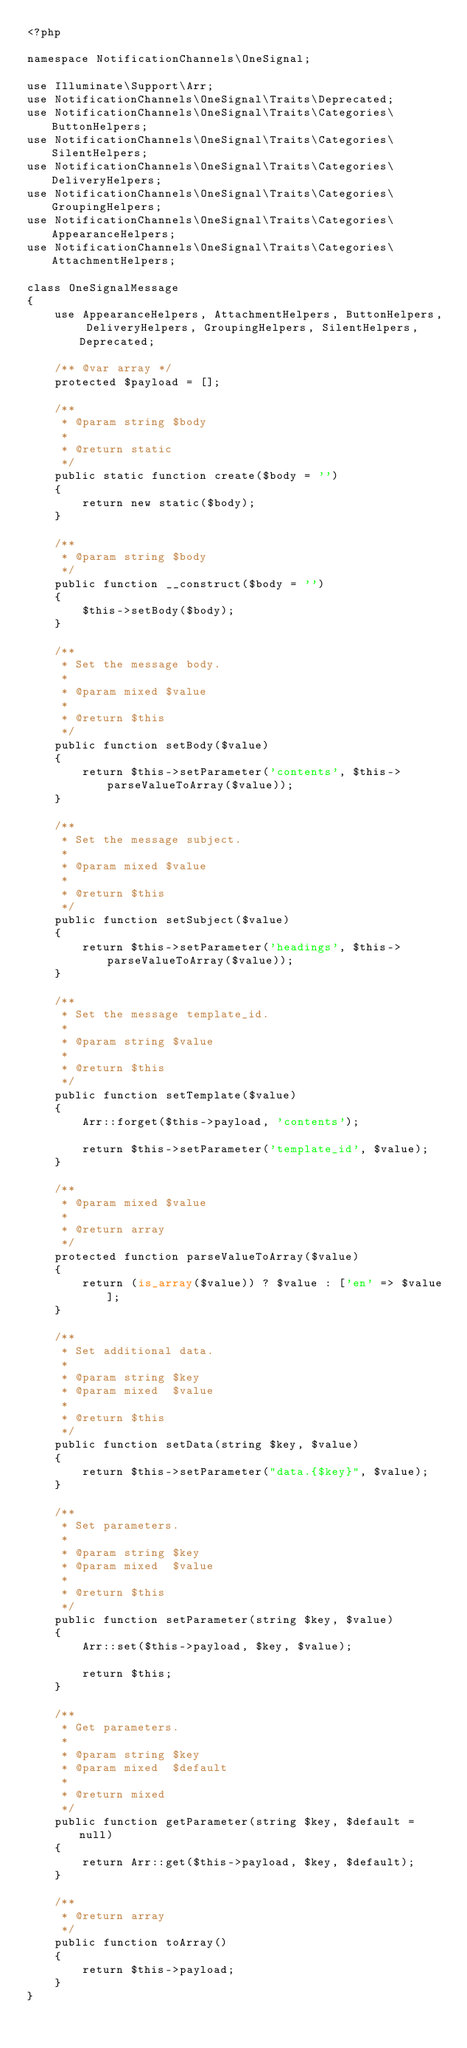<code> <loc_0><loc_0><loc_500><loc_500><_PHP_><?php

namespace NotificationChannels\OneSignal;

use Illuminate\Support\Arr;
use NotificationChannels\OneSignal\Traits\Deprecated;
use NotificationChannels\OneSignal\Traits\Categories\ButtonHelpers;
use NotificationChannels\OneSignal\Traits\Categories\SilentHelpers;
use NotificationChannels\OneSignal\Traits\Categories\DeliveryHelpers;
use NotificationChannels\OneSignal\Traits\Categories\GroupingHelpers;
use NotificationChannels\OneSignal\Traits\Categories\AppearanceHelpers;
use NotificationChannels\OneSignal\Traits\Categories\AttachmentHelpers;

class OneSignalMessage
{
    use AppearanceHelpers, AttachmentHelpers, ButtonHelpers, DeliveryHelpers, GroupingHelpers, SilentHelpers, Deprecated;

    /** @var array */
    protected $payload = [];

    /**
     * @param string $body
     *
     * @return static
     */
    public static function create($body = '')
    {
        return new static($body);
    }

    /**
     * @param string $body
     */
    public function __construct($body = '')
    {
        $this->setBody($body);
    }

    /**
     * Set the message body.
     *
     * @param mixed $value
     *
     * @return $this
     */
    public function setBody($value)
    {
        return $this->setParameter('contents', $this->parseValueToArray($value));
    }

    /**
     * Set the message subject.
     *
     * @param mixed $value
     *
     * @return $this
     */
    public function setSubject($value)
    {
        return $this->setParameter('headings', $this->parseValueToArray($value));
    }

    /**
     * Set the message template_id.
     *
     * @param string $value
     *
     * @return $this
     */
    public function setTemplate($value)
    {
        Arr::forget($this->payload, 'contents');

        return $this->setParameter('template_id', $value);
    }

    /**
     * @param mixed $value
     *
     * @return array
     */
    protected function parseValueToArray($value)
    {
        return (is_array($value)) ? $value : ['en' => $value];
    }

    /**
     * Set additional data.
     *
     * @param string $key
     * @param mixed  $value
     *
     * @return $this
     */
    public function setData(string $key, $value)
    {
        return $this->setParameter("data.{$key}", $value);
    }

    /**
     * Set parameters.
     *
     * @param string $key
     * @param mixed  $value
     *
     * @return $this
     */
    public function setParameter(string $key, $value)
    {
        Arr::set($this->payload, $key, $value);

        return $this;
    }

    /**
     * Get parameters.
     *
     * @param string $key
     * @param mixed  $default
     *
     * @return mixed
     */
    public function getParameter(string $key, $default = null)
    {
        return Arr::get($this->payload, $key, $default);
    }

    /**
     * @return array
     */
    public function toArray()
    {
        return $this->payload;
    }
}
</code> 